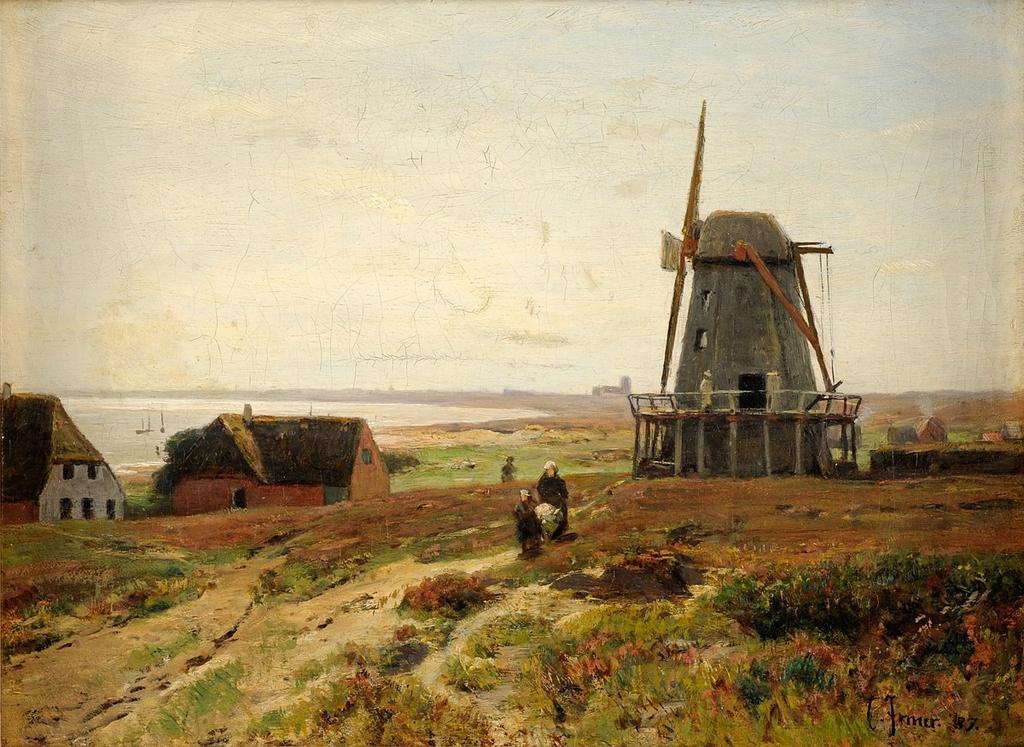Can you describe this image briefly? In this image we can see houses, windmill, people and other objects. In the background of the image there is water and other objects. At the bottom of the image there are grass and rocks. At the top of the image there is the sky. On the image there is a watermark. 